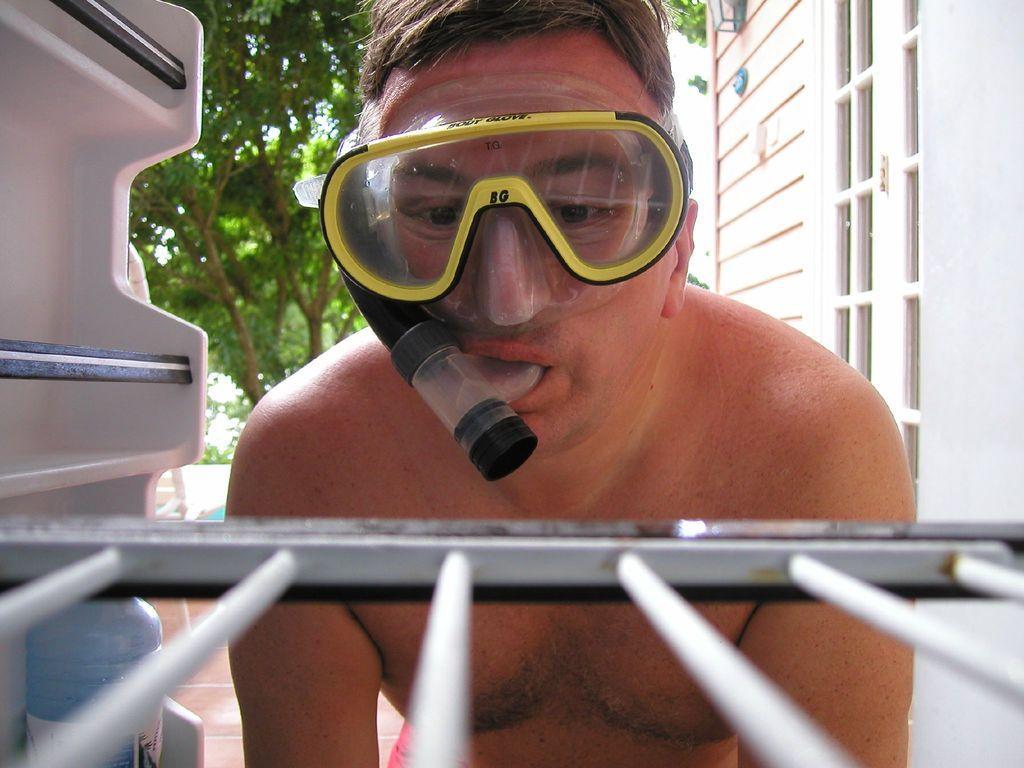Could you give a brief overview of what you see in this image? There is a person without having a shirt, wearing a oxygen cylinder, near a refrigerator, which is opened. In front of him, there is a shelf of refrigerator. In the background, there are trees, building and other objects. 